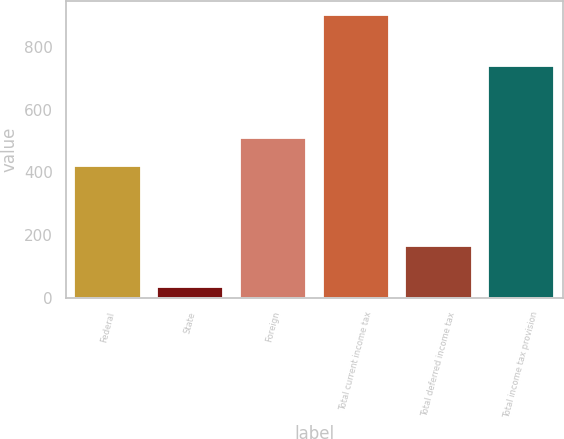<chart> <loc_0><loc_0><loc_500><loc_500><bar_chart><fcel>Federal<fcel>State<fcel>Foreign<fcel>Total current income tax<fcel>Total deferred income tax<fcel>Total income tax provision<nl><fcel>421<fcel>34<fcel>507.9<fcel>903<fcel>165<fcel>738<nl></chart> 